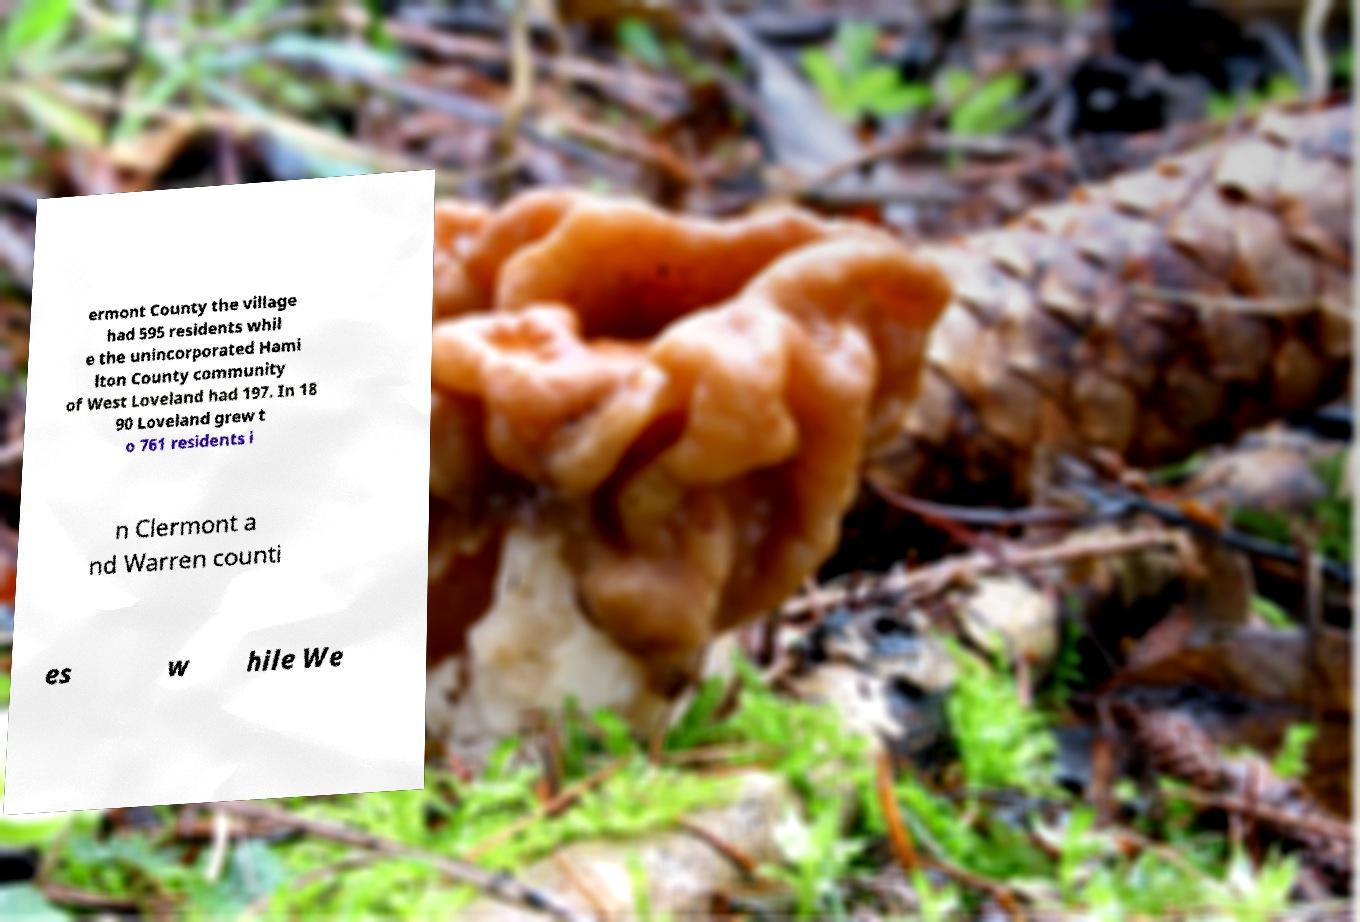Can you accurately transcribe the text from the provided image for me? ermont County the village had 595 residents whil e the unincorporated Hami lton County community of West Loveland had 197. In 18 90 Loveland grew t o 761 residents i n Clermont a nd Warren counti es w hile We 